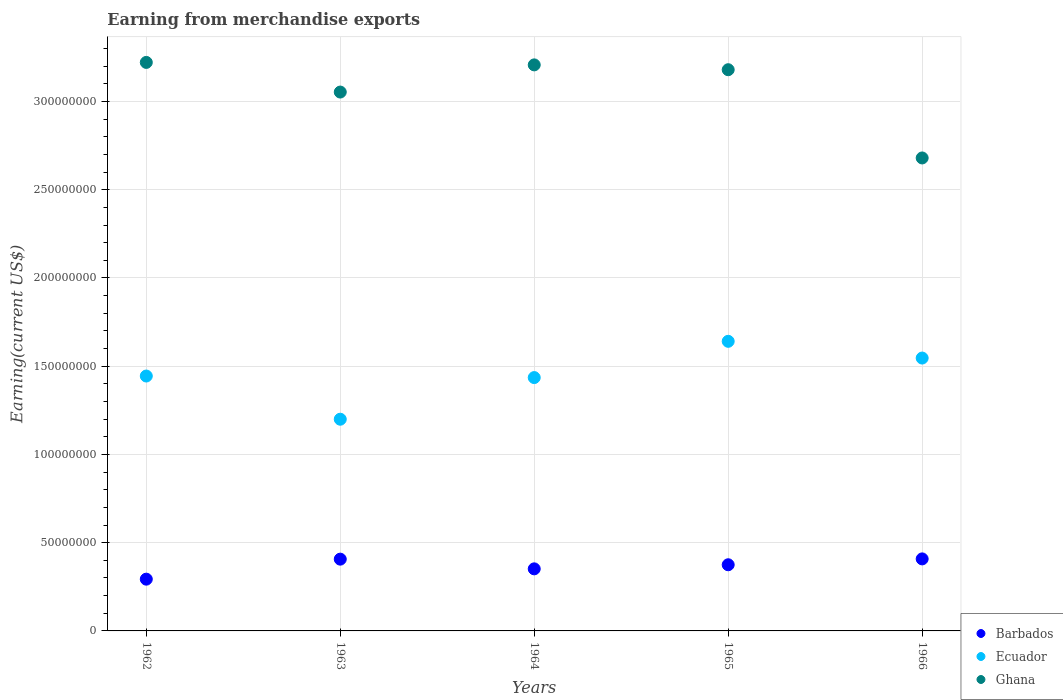Is the number of dotlines equal to the number of legend labels?
Keep it short and to the point. Yes. What is the amount earned from merchandise exports in Ecuador in 1965?
Offer a very short reply. 1.64e+08. Across all years, what is the maximum amount earned from merchandise exports in Ghana?
Make the answer very short. 3.22e+08. Across all years, what is the minimum amount earned from merchandise exports in Ecuador?
Ensure brevity in your answer.  1.20e+08. In which year was the amount earned from merchandise exports in Barbados maximum?
Ensure brevity in your answer.  1966. What is the total amount earned from merchandise exports in Ecuador in the graph?
Offer a terse response. 7.27e+08. What is the difference between the amount earned from merchandise exports in Ecuador in 1962 and that in 1963?
Ensure brevity in your answer.  2.45e+07. What is the difference between the amount earned from merchandise exports in Barbados in 1966 and the amount earned from merchandise exports in Ecuador in 1963?
Your response must be concise. -7.91e+07. What is the average amount earned from merchandise exports in Ghana per year?
Give a very brief answer. 3.07e+08. In the year 1965, what is the difference between the amount earned from merchandise exports in Ecuador and amount earned from merchandise exports in Barbados?
Provide a succinct answer. 1.27e+08. In how many years, is the amount earned from merchandise exports in Barbados greater than 320000000 US$?
Make the answer very short. 0. What is the ratio of the amount earned from merchandise exports in Ecuador in 1962 to that in 1966?
Your answer should be compact. 0.93. What is the difference between the highest and the second highest amount earned from merchandise exports in Ecuador?
Make the answer very short. 9.48e+06. What is the difference between the highest and the lowest amount earned from merchandise exports in Ghana?
Give a very brief answer. 5.41e+07. Is the sum of the amount earned from merchandise exports in Ecuador in 1965 and 1966 greater than the maximum amount earned from merchandise exports in Barbados across all years?
Offer a terse response. Yes. Is it the case that in every year, the sum of the amount earned from merchandise exports in Ecuador and amount earned from merchandise exports in Barbados  is greater than the amount earned from merchandise exports in Ghana?
Offer a very short reply. No. Are the values on the major ticks of Y-axis written in scientific E-notation?
Your response must be concise. No. Where does the legend appear in the graph?
Provide a short and direct response. Bottom right. What is the title of the graph?
Offer a terse response. Earning from merchandise exports. What is the label or title of the X-axis?
Ensure brevity in your answer.  Years. What is the label or title of the Y-axis?
Your response must be concise. Earning(current US$). What is the Earning(current US$) of Barbados in 1962?
Keep it short and to the point. 2.93e+07. What is the Earning(current US$) of Ecuador in 1962?
Make the answer very short. 1.44e+08. What is the Earning(current US$) of Ghana in 1962?
Make the answer very short. 3.22e+08. What is the Earning(current US$) of Barbados in 1963?
Offer a very short reply. 4.07e+07. What is the Earning(current US$) in Ecuador in 1963?
Offer a very short reply. 1.20e+08. What is the Earning(current US$) in Ghana in 1963?
Offer a very short reply. 3.05e+08. What is the Earning(current US$) in Barbados in 1964?
Your answer should be very brief. 3.52e+07. What is the Earning(current US$) of Ecuador in 1964?
Give a very brief answer. 1.44e+08. What is the Earning(current US$) in Ghana in 1964?
Your answer should be compact. 3.21e+08. What is the Earning(current US$) of Barbados in 1965?
Ensure brevity in your answer.  3.75e+07. What is the Earning(current US$) in Ecuador in 1965?
Make the answer very short. 1.64e+08. What is the Earning(current US$) in Ghana in 1965?
Your response must be concise. 3.18e+08. What is the Earning(current US$) in Barbados in 1966?
Make the answer very short. 4.08e+07. What is the Earning(current US$) in Ecuador in 1966?
Give a very brief answer. 1.55e+08. What is the Earning(current US$) of Ghana in 1966?
Provide a short and direct response. 2.68e+08. Across all years, what is the maximum Earning(current US$) in Barbados?
Give a very brief answer. 4.08e+07. Across all years, what is the maximum Earning(current US$) in Ecuador?
Offer a very short reply. 1.64e+08. Across all years, what is the maximum Earning(current US$) in Ghana?
Make the answer very short. 3.22e+08. Across all years, what is the minimum Earning(current US$) in Barbados?
Provide a succinct answer. 2.93e+07. Across all years, what is the minimum Earning(current US$) in Ecuador?
Keep it short and to the point. 1.20e+08. Across all years, what is the minimum Earning(current US$) of Ghana?
Your answer should be compact. 2.68e+08. What is the total Earning(current US$) of Barbados in the graph?
Your response must be concise. 1.83e+08. What is the total Earning(current US$) in Ecuador in the graph?
Provide a succinct answer. 7.27e+08. What is the total Earning(current US$) of Ghana in the graph?
Ensure brevity in your answer.  1.53e+09. What is the difference between the Earning(current US$) in Barbados in 1962 and that in 1963?
Make the answer very short. -1.13e+07. What is the difference between the Earning(current US$) in Ecuador in 1962 and that in 1963?
Provide a short and direct response. 2.45e+07. What is the difference between the Earning(current US$) of Ghana in 1962 and that in 1963?
Give a very brief answer. 1.68e+07. What is the difference between the Earning(current US$) of Barbados in 1962 and that in 1964?
Your answer should be compact. -5.84e+06. What is the difference between the Earning(current US$) in Ecuador in 1962 and that in 1964?
Your answer should be very brief. 8.79e+05. What is the difference between the Earning(current US$) of Ghana in 1962 and that in 1964?
Provide a succinct answer. 1.40e+06. What is the difference between the Earning(current US$) of Barbados in 1962 and that in 1965?
Provide a succinct answer. -8.16e+06. What is the difference between the Earning(current US$) in Ecuador in 1962 and that in 1965?
Make the answer very short. -1.97e+07. What is the difference between the Earning(current US$) in Ghana in 1962 and that in 1965?
Your answer should be compact. 4.14e+06. What is the difference between the Earning(current US$) of Barbados in 1962 and that in 1966?
Provide a short and direct response. -1.15e+07. What is the difference between the Earning(current US$) in Ecuador in 1962 and that in 1966?
Provide a short and direct response. -1.02e+07. What is the difference between the Earning(current US$) in Ghana in 1962 and that in 1966?
Provide a succinct answer. 5.41e+07. What is the difference between the Earning(current US$) in Barbados in 1963 and that in 1964?
Ensure brevity in your answer.  5.49e+06. What is the difference between the Earning(current US$) in Ecuador in 1963 and that in 1964?
Ensure brevity in your answer.  -2.36e+07. What is the difference between the Earning(current US$) in Ghana in 1963 and that in 1964?
Provide a short and direct response. -1.54e+07. What is the difference between the Earning(current US$) of Barbados in 1963 and that in 1965?
Your answer should be compact. 3.18e+06. What is the difference between the Earning(current US$) of Ecuador in 1963 and that in 1965?
Your answer should be compact. -4.41e+07. What is the difference between the Earning(current US$) in Ghana in 1963 and that in 1965?
Ensure brevity in your answer.  -1.27e+07. What is the difference between the Earning(current US$) of Barbados in 1963 and that in 1966?
Your response must be concise. -1.42e+05. What is the difference between the Earning(current US$) in Ecuador in 1963 and that in 1966?
Provide a succinct answer. -3.47e+07. What is the difference between the Earning(current US$) in Ghana in 1963 and that in 1966?
Give a very brief answer. 3.73e+07. What is the difference between the Earning(current US$) in Barbados in 1964 and that in 1965?
Give a very brief answer. -2.32e+06. What is the difference between the Earning(current US$) in Ecuador in 1964 and that in 1965?
Your response must be concise. -2.05e+07. What is the difference between the Earning(current US$) of Ghana in 1964 and that in 1965?
Your response must be concise. 2.74e+06. What is the difference between the Earning(current US$) in Barbados in 1964 and that in 1966?
Provide a succinct answer. -5.64e+06. What is the difference between the Earning(current US$) in Ecuador in 1964 and that in 1966?
Provide a short and direct response. -1.11e+07. What is the difference between the Earning(current US$) of Ghana in 1964 and that in 1966?
Provide a short and direct response. 5.27e+07. What is the difference between the Earning(current US$) of Barbados in 1965 and that in 1966?
Make the answer very short. -3.32e+06. What is the difference between the Earning(current US$) in Ecuador in 1965 and that in 1966?
Provide a succinct answer. 9.48e+06. What is the difference between the Earning(current US$) in Barbados in 1962 and the Earning(current US$) in Ecuador in 1963?
Offer a very short reply. -9.06e+07. What is the difference between the Earning(current US$) of Barbados in 1962 and the Earning(current US$) of Ghana in 1963?
Give a very brief answer. -2.76e+08. What is the difference between the Earning(current US$) in Ecuador in 1962 and the Earning(current US$) in Ghana in 1963?
Offer a very short reply. -1.61e+08. What is the difference between the Earning(current US$) in Barbados in 1962 and the Earning(current US$) in Ecuador in 1964?
Keep it short and to the point. -1.14e+08. What is the difference between the Earning(current US$) of Barbados in 1962 and the Earning(current US$) of Ghana in 1964?
Make the answer very short. -2.91e+08. What is the difference between the Earning(current US$) of Ecuador in 1962 and the Earning(current US$) of Ghana in 1964?
Your answer should be very brief. -1.76e+08. What is the difference between the Earning(current US$) of Barbados in 1962 and the Earning(current US$) of Ecuador in 1965?
Offer a very short reply. -1.35e+08. What is the difference between the Earning(current US$) of Barbados in 1962 and the Earning(current US$) of Ghana in 1965?
Offer a terse response. -2.89e+08. What is the difference between the Earning(current US$) in Ecuador in 1962 and the Earning(current US$) in Ghana in 1965?
Offer a very short reply. -1.74e+08. What is the difference between the Earning(current US$) in Barbados in 1962 and the Earning(current US$) in Ecuador in 1966?
Keep it short and to the point. -1.25e+08. What is the difference between the Earning(current US$) in Barbados in 1962 and the Earning(current US$) in Ghana in 1966?
Keep it short and to the point. -2.39e+08. What is the difference between the Earning(current US$) of Ecuador in 1962 and the Earning(current US$) of Ghana in 1966?
Your response must be concise. -1.24e+08. What is the difference between the Earning(current US$) in Barbados in 1963 and the Earning(current US$) in Ecuador in 1964?
Offer a very short reply. -1.03e+08. What is the difference between the Earning(current US$) in Barbados in 1963 and the Earning(current US$) in Ghana in 1964?
Provide a short and direct response. -2.80e+08. What is the difference between the Earning(current US$) in Ecuador in 1963 and the Earning(current US$) in Ghana in 1964?
Provide a succinct answer. -2.01e+08. What is the difference between the Earning(current US$) in Barbados in 1963 and the Earning(current US$) in Ecuador in 1965?
Your answer should be very brief. -1.23e+08. What is the difference between the Earning(current US$) of Barbados in 1963 and the Earning(current US$) of Ghana in 1965?
Your answer should be very brief. -2.77e+08. What is the difference between the Earning(current US$) of Ecuador in 1963 and the Earning(current US$) of Ghana in 1965?
Your answer should be very brief. -1.98e+08. What is the difference between the Earning(current US$) of Barbados in 1963 and the Earning(current US$) of Ecuador in 1966?
Give a very brief answer. -1.14e+08. What is the difference between the Earning(current US$) of Barbados in 1963 and the Earning(current US$) of Ghana in 1966?
Provide a succinct answer. -2.27e+08. What is the difference between the Earning(current US$) of Ecuador in 1963 and the Earning(current US$) of Ghana in 1966?
Ensure brevity in your answer.  -1.48e+08. What is the difference between the Earning(current US$) of Barbados in 1964 and the Earning(current US$) of Ecuador in 1965?
Your response must be concise. -1.29e+08. What is the difference between the Earning(current US$) in Barbados in 1964 and the Earning(current US$) in Ghana in 1965?
Give a very brief answer. -2.83e+08. What is the difference between the Earning(current US$) in Ecuador in 1964 and the Earning(current US$) in Ghana in 1965?
Give a very brief answer. -1.74e+08. What is the difference between the Earning(current US$) of Barbados in 1964 and the Earning(current US$) of Ecuador in 1966?
Your response must be concise. -1.19e+08. What is the difference between the Earning(current US$) in Barbados in 1964 and the Earning(current US$) in Ghana in 1966?
Your answer should be very brief. -2.33e+08. What is the difference between the Earning(current US$) of Ecuador in 1964 and the Earning(current US$) of Ghana in 1966?
Provide a short and direct response. -1.24e+08. What is the difference between the Earning(current US$) of Barbados in 1965 and the Earning(current US$) of Ecuador in 1966?
Offer a terse response. -1.17e+08. What is the difference between the Earning(current US$) of Barbados in 1965 and the Earning(current US$) of Ghana in 1966?
Keep it short and to the point. -2.31e+08. What is the difference between the Earning(current US$) in Ecuador in 1965 and the Earning(current US$) in Ghana in 1966?
Your answer should be compact. -1.04e+08. What is the average Earning(current US$) of Barbados per year?
Make the answer very short. 3.67e+07. What is the average Earning(current US$) of Ecuador per year?
Offer a terse response. 1.45e+08. What is the average Earning(current US$) in Ghana per year?
Your answer should be very brief. 3.07e+08. In the year 1962, what is the difference between the Earning(current US$) of Barbados and Earning(current US$) of Ecuador?
Offer a very short reply. -1.15e+08. In the year 1962, what is the difference between the Earning(current US$) of Barbados and Earning(current US$) of Ghana?
Keep it short and to the point. -2.93e+08. In the year 1962, what is the difference between the Earning(current US$) in Ecuador and Earning(current US$) in Ghana?
Make the answer very short. -1.78e+08. In the year 1963, what is the difference between the Earning(current US$) of Barbados and Earning(current US$) of Ecuador?
Your answer should be compact. -7.93e+07. In the year 1963, what is the difference between the Earning(current US$) in Barbados and Earning(current US$) in Ghana?
Give a very brief answer. -2.65e+08. In the year 1963, what is the difference between the Earning(current US$) in Ecuador and Earning(current US$) in Ghana?
Give a very brief answer. -1.85e+08. In the year 1964, what is the difference between the Earning(current US$) of Barbados and Earning(current US$) of Ecuador?
Ensure brevity in your answer.  -1.08e+08. In the year 1964, what is the difference between the Earning(current US$) of Barbados and Earning(current US$) of Ghana?
Offer a terse response. -2.86e+08. In the year 1964, what is the difference between the Earning(current US$) in Ecuador and Earning(current US$) in Ghana?
Give a very brief answer. -1.77e+08. In the year 1965, what is the difference between the Earning(current US$) of Barbados and Earning(current US$) of Ecuador?
Offer a terse response. -1.27e+08. In the year 1965, what is the difference between the Earning(current US$) of Barbados and Earning(current US$) of Ghana?
Your answer should be compact. -2.81e+08. In the year 1965, what is the difference between the Earning(current US$) of Ecuador and Earning(current US$) of Ghana?
Provide a succinct answer. -1.54e+08. In the year 1966, what is the difference between the Earning(current US$) in Barbados and Earning(current US$) in Ecuador?
Provide a succinct answer. -1.14e+08. In the year 1966, what is the difference between the Earning(current US$) in Barbados and Earning(current US$) in Ghana?
Ensure brevity in your answer.  -2.27e+08. In the year 1966, what is the difference between the Earning(current US$) in Ecuador and Earning(current US$) in Ghana?
Provide a succinct answer. -1.13e+08. What is the ratio of the Earning(current US$) of Barbados in 1962 to that in 1963?
Offer a very short reply. 0.72. What is the ratio of the Earning(current US$) of Ecuador in 1962 to that in 1963?
Make the answer very short. 1.2. What is the ratio of the Earning(current US$) of Ghana in 1962 to that in 1963?
Your answer should be compact. 1.05. What is the ratio of the Earning(current US$) of Barbados in 1962 to that in 1964?
Offer a terse response. 0.83. What is the ratio of the Earning(current US$) of Ecuador in 1962 to that in 1964?
Ensure brevity in your answer.  1.01. What is the ratio of the Earning(current US$) in Barbados in 1962 to that in 1965?
Keep it short and to the point. 0.78. What is the ratio of the Earning(current US$) in Ecuador in 1962 to that in 1965?
Provide a short and direct response. 0.88. What is the ratio of the Earning(current US$) of Ghana in 1962 to that in 1965?
Give a very brief answer. 1.01. What is the ratio of the Earning(current US$) of Barbados in 1962 to that in 1966?
Offer a terse response. 0.72. What is the ratio of the Earning(current US$) of Ecuador in 1962 to that in 1966?
Your answer should be compact. 0.93. What is the ratio of the Earning(current US$) of Ghana in 1962 to that in 1966?
Your response must be concise. 1.2. What is the ratio of the Earning(current US$) in Barbados in 1963 to that in 1964?
Ensure brevity in your answer.  1.16. What is the ratio of the Earning(current US$) of Ecuador in 1963 to that in 1964?
Provide a short and direct response. 0.84. What is the ratio of the Earning(current US$) in Barbados in 1963 to that in 1965?
Make the answer very short. 1.08. What is the ratio of the Earning(current US$) of Ecuador in 1963 to that in 1965?
Offer a terse response. 0.73. What is the ratio of the Earning(current US$) of Ghana in 1963 to that in 1965?
Keep it short and to the point. 0.96. What is the ratio of the Earning(current US$) of Barbados in 1963 to that in 1966?
Your answer should be compact. 1. What is the ratio of the Earning(current US$) in Ecuador in 1963 to that in 1966?
Make the answer very short. 0.78. What is the ratio of the Earning(current US$) of Ghana in 1963 to that in 1966?
Make the answer very short. 1.14. What is the ratio of the Earning(current US$) in Barbados in 1964 to that in 1965?
Ensure brevity in your answer.  0.94. What is the ratio of the Earning(current US$) of Ecuador in 1964 to that in 1965?
Keep it short and to the point. 0.87. What is the ratio of the Earning(current US$) in Ghana in 1964 to that in 1965?
Offer a terse response. 1.01. What is the ratio of the Earning(current US$) in Barbados in 1964 to that in 1966?
Give a very brief answer. 0.86. What is the ratio of the Earning(current US$) of Ecuador in 1964 to that in 1966?
Provide a succinct answer. 0.93. What is the ratio of the Earning(current US$) in Ghana in 1964 to that in 1966?
Offer a very short reply. 1.2. What is the ratio of the Earning(current US$) in Barbados in 1965 to that in 1966?
Make the answer very short. 0.92. What is the ratio of the Earning(current US$) in Ecuador in 1965 to that in 1966?
Make the answer very short. 1.06. What is the ratio of the Earning(current US$) of Ghana in 1965 to that in 1966?
Keep it short and to the point. 1.19. What is the difference between the highest and the second highest Earning(current US$) of Barbados?
Offer a terse response. 1.42e+05. What is the difference between the highest and the second highest Earning(current US$) of Ecuador?
Your response must be concise. 9.48e+06. What is the difference between the highest and the second highest Earning(current US$) of Ghana?
Your response must be concise. 1.40e+06. What is the difference between the highest and the lowest Earning(current US$) in Barbados?
Provide a succinct answer. 1.15e+07. What is the difference between the highest and the lowest Earning(current US$) of Ecuador?
Give a very brief answer. 4.41e+07. What is the difference between the highest and the lowest Earning(current US$) of Ghana?
Provide a short and direct response. 5.41e+07. 